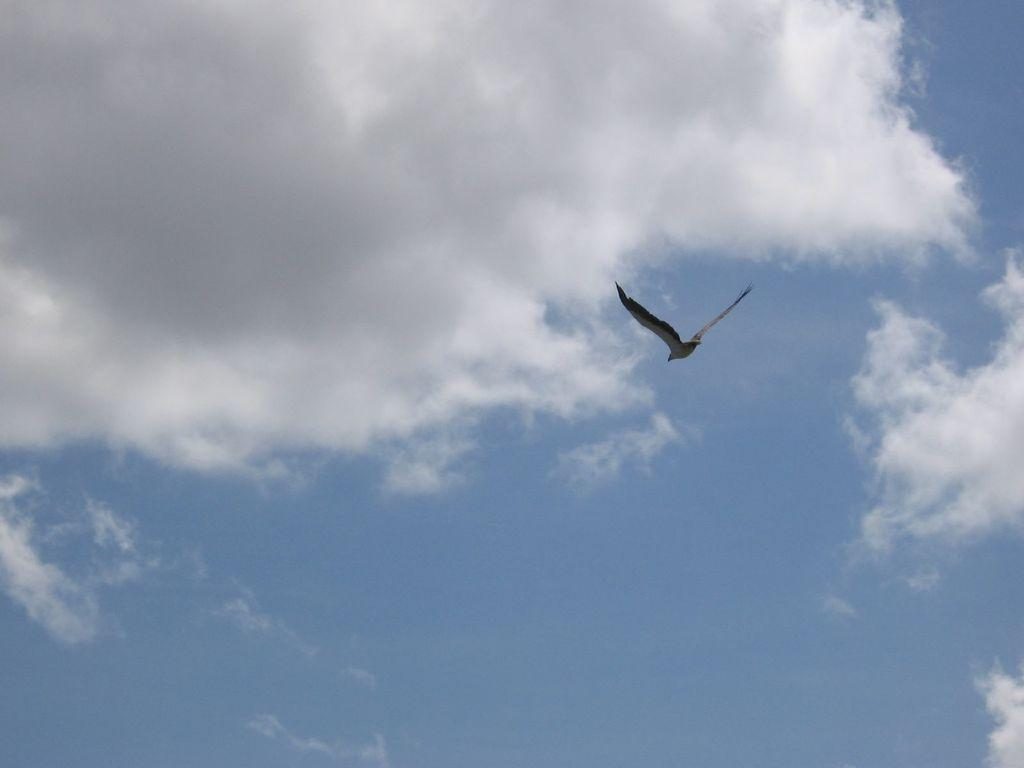What is the main subject of the image? There is a bird flying in the image. What can be seen in the background of the image? The sky is visible in the background of the image. What is the condition of the sky in the image? There are clouds in the sky. What verse is the bird reciting while flying in the image? There is no indication in the image that the bird is reciting a verse, so it cannot be determined from the picture. 